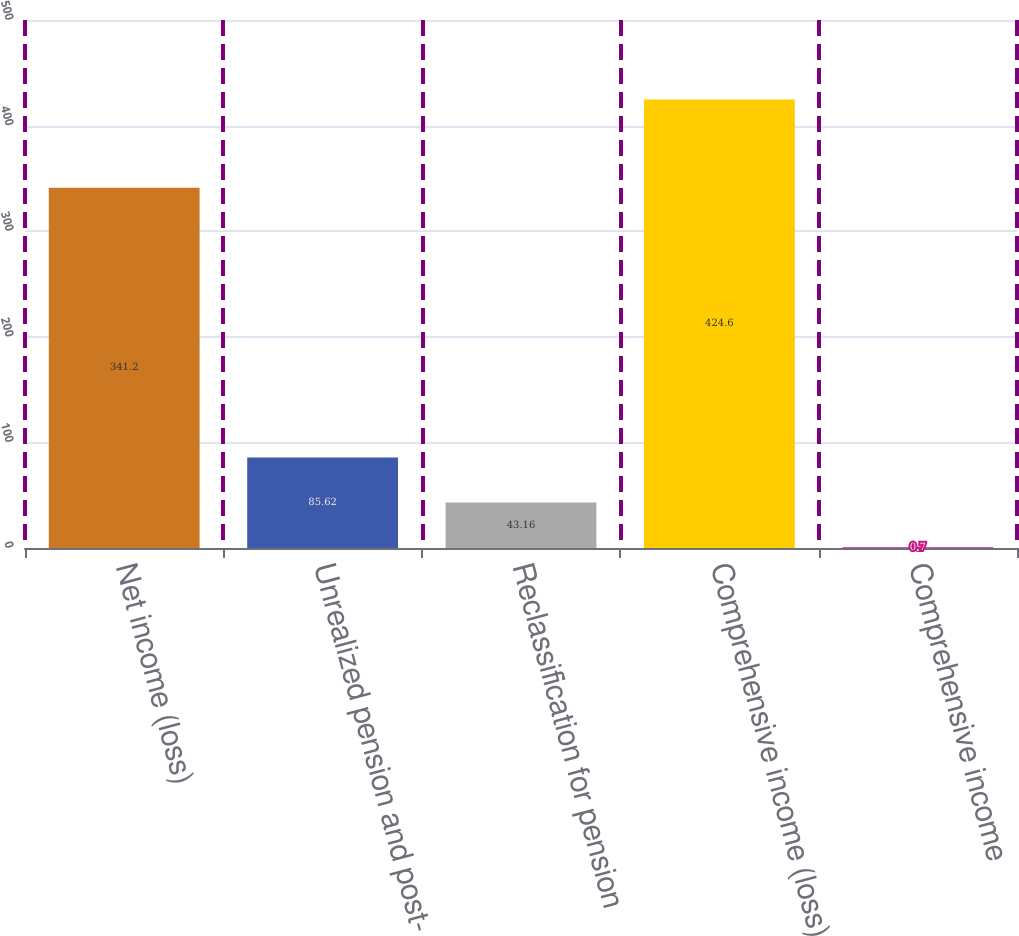<chart> <loc_0><loc_0><loc_500><loc_500><bar_chart><fcel>Net income (loss)<fcel>Unrealized pension and post-<fcel>Reclassification for pension<fcel>Comprehensive income (loss)<fcel>Comprehensive income<nl><fcel>341.2<fcel>85.62<fcel>43.16<fcel>424.6<fcel>0.7<nl></chart> 